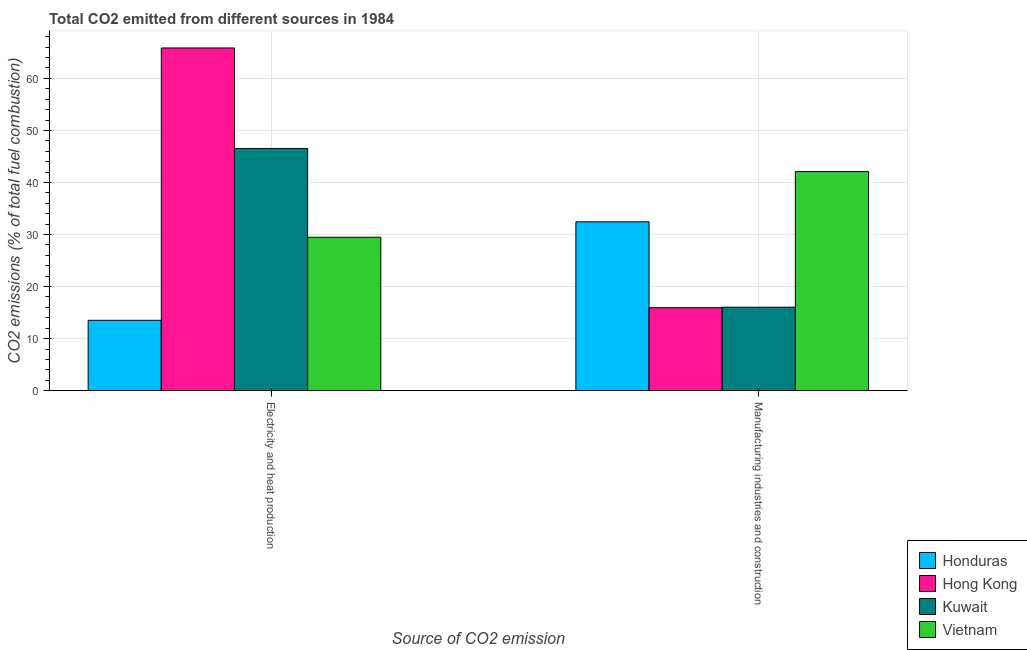How many different coloured bars are there?
Offer a terse response. 4. Are the number of bars per tick equal to the number of legend labels?
Make the answer very short. Yes. What is the label of the 2nd group of bars from the left?
Provide a succinct answer. Manufacturing industries and construction. What is the co2 emissions due to electricity and heat production in Vietnam?
Offer a very short reply. 29.48. Across all countries, what is the maximum co2 emissions due to manufacturing industries?
Make the answer very short. 42.09. Across all countries, what is the minimum co2 emissions due to electricity and heat production?
Your answer should be very brief. 13.51. In which country was the co2 emissions due to manufacturing industries maximum?
Your answer should be very brief. Vietnam. In which country was the co2 emissions due to manufacturing industries minimum?
Offer a very short reply. Hong Kong. What is the total co2 emissions due to electricity and heat production in the graph?
Give a very brief answer. 155.37. What is the difference between the co2 emissions due to electricity and heat production in Vietnam and that in Kuwait?
Keep it short and to the point. -17.06. What is the difference between the co2 emissions due to electricity and heat production in Kuwait and the co2 emissions due to manufacturing industries in Hong Kong?
Your response must be concise. 30.59. What is the average co2 emissions due to manufacturing industries per country?
Ensure brevity in your answer.  26.62. What is the difference between the co2 emissions due to manufacturing industries and co2 emissions due to electricity and heat production in Hong Kong?
Your answer should be very brief. -49.91. What is the ratio of the co2 emissions due to electricity and heat production in Honduras to that in Vietnam?
Make the answer very short. 0.46. Is the co2 emissions due to manufacturing industries in Honduras less than that in Hong Kong?
Your answer should be compact. No. What does the 4th bar from the left in Electricity and heat production represents?
Provide a short and direct response. Vietnam. What does the 1st bar from the right in Electricity and heat production represents?
Provide a succinct answer. Vietnam. How many bars are there?
Your answer should be very brief. 8. Does the graph contain any zero values?
Ensure brevity in your answer.  No. Does the graph contain grids?
Offer a terse response. Yes. Where does the legend appear in the graph?
Provide a succinct answer. Bottom right. How many legend labels are there?
Your answer should be compact. 4. How are the legend labels stacked?
Make the answer very short. Vertical. What is the title of the graph?
Offer a very short reply. Total CO2 emitted from different sources in 1984. What is the label or title of the X-axis?
Make the answer very short. Source of CO2 emission. What is the label or title of the Y-axis?
Keep it short and to the point. CO2 emissions (% of total fuel combustion). What is the CO2 emissions (% of total fuel combustion) in Honduras in Electricity and heat production?
Your answer should be compact. 13.51. What is the CO2 emissions (% of total fuel combustion) of Hong Kong in Electricity and heat production?
Offer a terse response. 65.84. What is the CO2 emissions (% of total fuel combustion) of Kuwait in Electricity and heat production?
Your answer should be compact. 46.53. What is the CO2 emissions (% of total fuel combustion) in Vietnam in Electricity and heat production?
Ensure brevity in your answer.  29.48. What is the CO2 emissions (% of total fuel combustion) of Honduras in Manufacturing industries and construction?
Your answer should be very brief. 32.43. What is the CO2 emissions (% of total fuel combustion) in Hong Kong in Manufacturing industries and construction?
Your answer should be very brief. 15.94. What is the CO2 emissions (% of total fuel combustion) of Kuwait in Manufacturing industries and construction?
Provide a succinct answer. 16.03. What is the CO2 emissions (% of total fuel combustion) of Vietnam in Manufacturing industries and construction?
Your response must be concise. 42.09. Across all Source of CO2 emission, what is the maximum CO2 emissions (% of total fuel combustion) in Honduras?
Your response must be concise. 32.43. Across all Source of CO2 emission, what is the maximum CO2 emissions (% of total fuel combustion) in Hong Kong?
Your response must be concise. 65.84. Across all Source of CO2 emission, what is the maximum CO2 emissions (% of total fuel combustion) of Kuwait?
Offer a terse response. 46.53. Across all Source of CO2 emission, what is the maximum CO2 emissions (% of total fuel combustion) in Vietnam?
Give a very brief answer. 42.09. Across all Source of CO2 emission, what is the minimum CO2 emissions (% of total fuel combustion) in Honduras?
Keep it short and to the point. 13.51. Across all Source of CO2 emission, what is the minimum CO2 emissions (% of total fuel combustion) in Hong Kong?
Your answer should be compact. 15.94. Across all Source of CO2 emission, what is the minimum CO2 emissions (% of total fuel combustion) of Kuwait?
Ensure brevity in your answer.  16.03. Across all Source of CO2 emission, what is the minimum CO2 emissions (% of total fuel combustion) of Vietnam?
Offer a terse response. 29.48. What is the total CO2 emissions (% of total fuel combustion) of Honduras in the graph?
Offer a terse response. 45.95. What is the total CO2 emissions (% of total fuel combustion) of Hong Kong in the graph?
Offer a very short reply. 81.78. What is the total CO2 emissions (% of total fuel combustion) of Kuwait in the graph?
Provide a short and direct response. 62.56. What is the total CO2 emissions (% of total fuel combustion) of Vietnam in the graph?
Provide a succinct answer. 71.57. What is the difference between the CO2 emissions (% of total fuel combustion) of Honduras in Electricity and heat production and that in Manufacturing industries and construction?
Offer a terse response. -18.92. What is the difference between the CO2 emissions (% of total fuel combustion) of Hong Kong in Electricity and heat production and that in Manufacturing industries and construction?
Your answer should be very brief. 49.91. What is the difference between the CO2 emissions (% of total fuel combustion) of Kuwait in Electricity and heat production and that in Manufacturing industries and construction?
Ensure brevity in your answer.  30.5. What is the difference between the CO2 emissions (% of total fuel combustion) in Vietnam in Electricity and heat production and that in Manufacturing industries and construction?
Your answer should be compact. -12.62. What is the difference between the CO2 emissions (% of total fuel combustion) of Honduras in Electricity and heat production and the CO2 emissions (% of total fuel combustion) of Hong Kong in Manufacturing industries and construction?
Your answer should be very brief. -2.43. What is the difference between the CO2 emissions (% of total fuel combustion) in Honduras in Electricity and heat production and the CO2 emissions (% of total fuel combustion) in Kuwait in Manufacturing industries and construction?
Keep it short and to the point. -2.52. What is the difference between the CO2 emissions (% of total fuel combustion) in Honduras in Electricity and heat production and the CO2 emissions (% of total fuel combustion) in Vietnam in Manufacturing industries and construction?
Keep it short and to the point. -28.58. What is the difference between the CO2 emissions (% of total fuel combustion) of Hong Kong in Electricity and heat production and the CO2 emissions (% of total fuel combustion) of Kuwait in Manufacturing industries and construction?
Give a very brief answer. 49.81. What is the difference between the CO2 emissions (% of total fuel combustion) in Hong Kong in Electricity and heat production and the CO2 emissions (% of total fuel combustion) in Vietnam in Manufacturing industries and construction?
Offer a terse response. 23.75. What is the difference between the CO2 emissions (% of total fuel combustion) of Kuwait in Electricity and heat production and the CO2 emissions (% of total fuel combustion) of Vietnam in Manufacturing industries and construction?
Your answer should be very brief. 4.44. What is the average CO2 emissions (% of total fuel combustion) of Honduras per Source of CO2 emission?
Provide a succinct answer. 22.97. What is the average CO2 emissions (% of total fuel combustion) in Hong Kong per Source of CO2 emission?
Ensure brevity in your answer.  40.89. What is the average CO2 emissions (% of total fuel combustion) of Kuwait per Source of CO2 emission?
Ensure brevity in your answer.  31.28. What is the average CO2 emissions (% of total fuel combustion) in Vietnam per Source of CO2 emission?
Ensure brevity in your answer.  35.78. What is the difference between the CO2 emissions (% of total fuel combustion) of Honduras and CO2 emissions (% of total fuel combustion) of Hong Kong in Electricity and heat production?
Offer a terse response. -52.33. What is the difference between the CO2 emissions (% of total fuel combustion) of Honduras and CO2 emissions (% of total fuel combustion) of Kuwait in Electricity and heat production?
Your response must be concise. -33.02. What is the difference between the CO2 emissions (% of total fuel combustion) in Honduras and CO2 emissions (% of total fuel combustion) in Vietnam in Electricity and heat production?
Provide a short and direct response. -15.96. What is the difference between the CO2 emissions (% of total fuel combustion) in Hong Kong and CO2 emissions (% of total fuel combustion) in Kuwait in Electricity and heat production?
Your response must be concise. 19.31. What is the difference between the CO2 emissions (% of total fuel combustion) of Hong Kong and CO2 emissions (% of total fuel combustion) of Vietnam in Electricity and heat production?
Keep it short and to the point. 36.37. What is the difference between the CO2 emissions (% of total fuel combustion) in Kuwait and CO2 emissions (% of total fuel combustion) in Vietnam in Electricity and heat production?
Ensure brevity in your answer.  17.06. What is the difference between the CO2 emissions (% of total fuel combustion) of Honduras and CO2 emissions (% of total fuel combustion) of Hong Kong in Manufacturing industries and construction?
Your response must be concise. 16.49. What is the difference between the CO2 emissions (% of total fuel combustion) in Honduras and CO2 emissions (% of total fuel combustion) in Kuwait in Manufacturing industries and construction?
Make the answer very short. 16.4. What is the difference between the CO2 emissions (% of total fuel combustion) of Honduras and CO2 emissions (% of total fuel combustion) of Vietnam in Manufacturing industries and construction?
Make the answer very short. -9.66. What is the difference between the CO2 emissions (% of total fuel combustion) of Hong Kong and CO2 emissions (% of total fuel combustion) of Kuwait in Manufacturing industries and construction?
Make the answer very short. -0.09. What is the difference between the CO2 emissions (% of total fuel combustion) in Hong Kong and CO2 emissions (% of total fuel combustion) in Vietnam in Manufacturing industries and construction?
Ensure brevity in your answer.  -26.15. What is the difference between the CO2 emissions (% of total fuel combustion) in Kuwait and CO2 emissions (% of total fuel combustion) in Vietnam in Manufacturing industries and construction?
Provide a succinct answer. -26.06. What is the ratio of the CO2 emissions (% of total fuel combustion) in Honduras in Electricity and heat production to that in Manufacturing industries and construction?
Ensure brevity in your answer.  0.42. What is the ratio of the CO2 emissions (% of total fuel combustion) of Hong Kong in Electricity and heat production to that in Manufacturing industries and construction?
Provide a succinct answer. 4.13. What is the ratio of the CO2 emissions (% of total fuel combustion) in Kuwait in Electricity and heat production to that in Manufacturing industries and construction?
Ensure brevity in your answer.  2.9. What is the ratio of the CO2 emissions (% of total fuel combustion) of Vietnam in Electricity and heat production to that in Manufacturing industries and construction?
Offer a very short reply. 0.7. What is the difference between the highest and the second highest CO2 emissions (% of total fuel combustion) in Honduras?
Ensure brevity in your answer.  18.92. What is the difference between the highest and the second highest CO2 emissions (% of total fuel combustion) of Hong Kong?
Provide a short and direct response. 49.91. What is the difference between the highest and the second highest CO2 emissions (% of total fuel combustion) of Kuwait?
Offer a very short reply. 30.5. What is the difference between the highest and the second highest CO2 emissions (% of total fuel combustion) in Vietnam?
Give a very brief answer. 12.62. What is the difference between the highest and the lowest CO2 emissions (% of total fuel combustion) in Honduras?
Ensure brevity in your answer.  18.92. What is the difference between the highest and the lowest CO2 emissions (% of total fuel combustion) of Hong Kong?
Give a very brief answer. 49.91. What is the difference between the highest and the lowest CO2 emissions (% of total fuel combustion) in Kuwait?
Make the answer very short. 30.5. What is the difference between the highest and the lowest CO2 emissions (% of total fuel combustion) of Vietnam?
Make the answer very short. 12.62. 